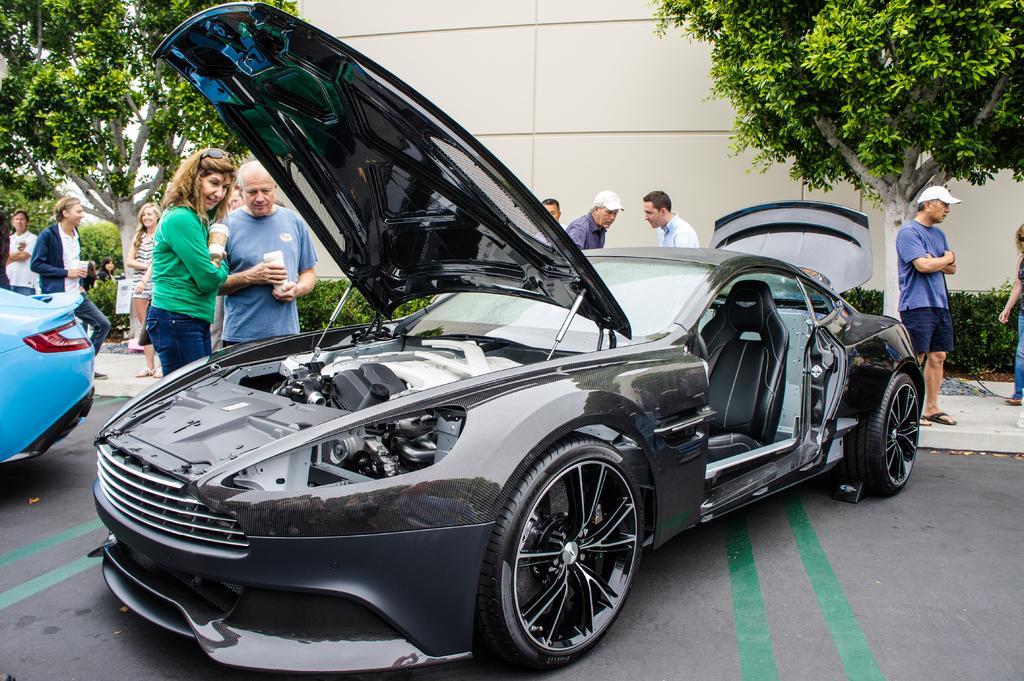Please provide a concise description of this image. In this image we can see motor vehicles on the road and persons standing. In the background there are sky, trees, bushes and building. 